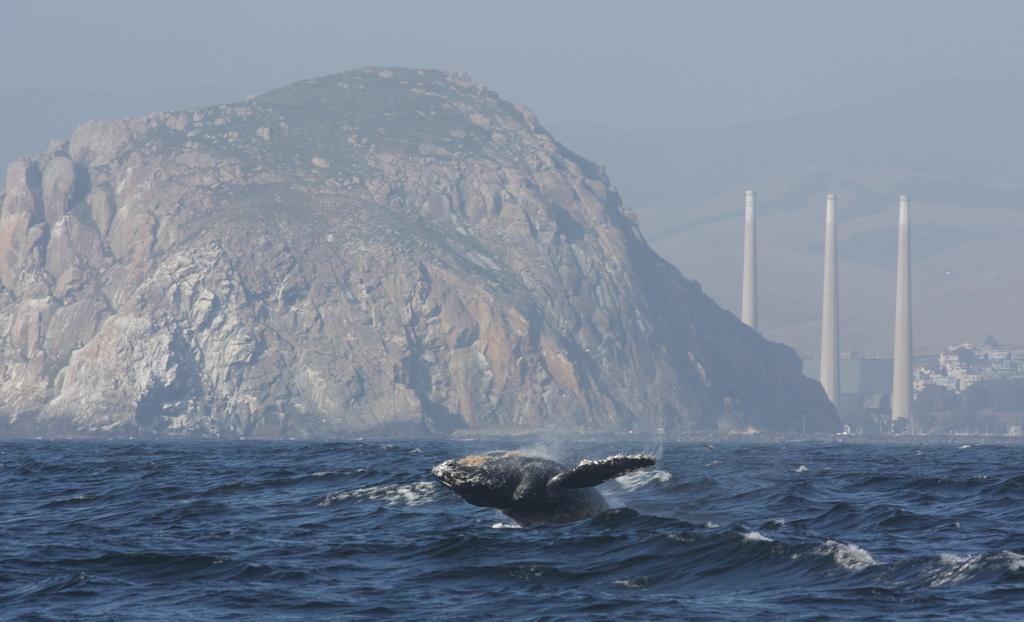What is in the water in the image? There is a fish in the water in the image. What can be seen in the distance in the image? There is a mountain and buildings in the backdrop of the image. How would you describe the sky in the image? The sky is foggy in the image. What type of waste can be seen floating in the water in the image? There is no waste visible in the water in the image; it only shows a fish. Can you hear the band playing music in the image? There is no band present in the image, so it is not possible to hear them playing music. 